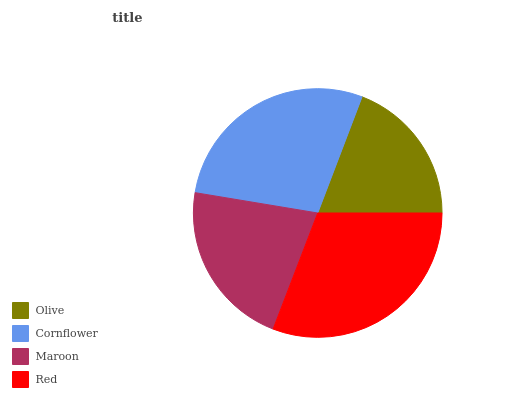Is Olive the minimum?
Answer yes or no. Yes. Is Red the maximum?
Answer yes or no. Yes. Is Cornflower the minimum?
Answer yes or no. No. Is Cornflower the maximum?
Answer yes or no. No. Is Cornflower greater than Olive?
Answer yes or no. Yes. Is Olive less than Cornflower?
Answer yes or no. Yes. Is Olive greater than Cornflower?
Answer yes or no. No. Is Cornflower less than Olive?
Answer yes or no. No. Is Cornflower the high median?
Answer yes or no. Yes. Is Maroon the low median?
Answer yes or no. Yes. Is Olive the high median?
Answer yes or no. No. Is Olive the low median?
Answer yes or no. No. 